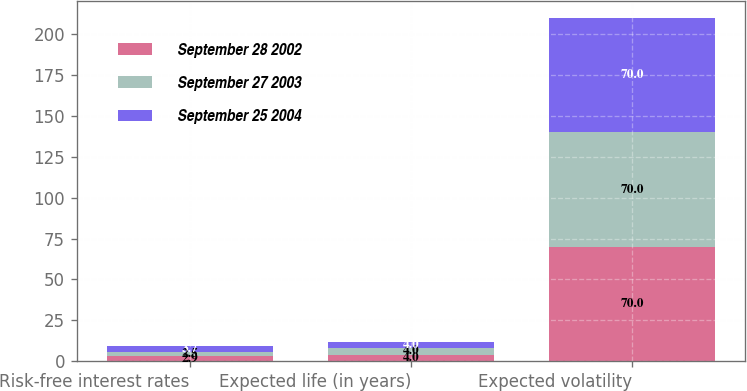<chart> <loc_0><loc_0><loc_500><loc_500><stacked_bar_chart><ecel><fcel>Risk-free interest rates<fcel>Expected life (in years)<fcel>Expected volatility<nl><fcel>September 28 2002<fcel>2.9<fcel>4<fcel>70<nl><fcel>September 27 2003<fcel>2.5<fcel>4<fcel>70<nl><fcel>September 25 2004<fcel>3.7<fcel>4<fcel>70<nl></chart> 